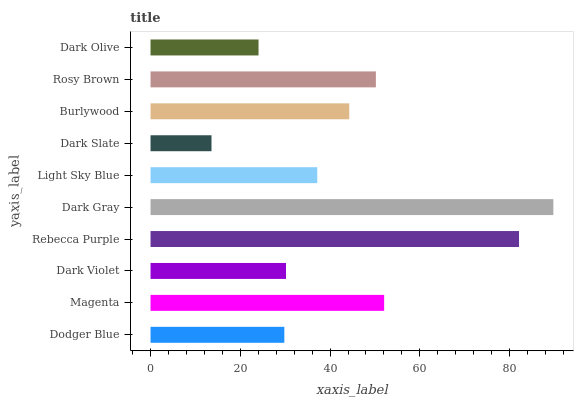Is Dark Slate the minimum?
Answer yes or no. Yes. Is Dark Gray the maximum?
Answer yes or no. Yes. Is Magenta the minimum?
Answer yes or no. No. Is Magenta the maximum?
Answer yes or no. No. Is Magenta greater than Dodger Blue?
Answer yes or no. Yes. Is Dodger Blue less than Magenta?
Answer yes or no. Yes. Is Dodger Blue greater than Magenta?
Answer yes or no. No. Is Magenta less than Dodger Blue?
Answer yes or no. No. Is Burlywood the high median?
Answer yes or no. Yes. Is Light Sky Blue the low median?
Answer yes or no. Yes. Is Dark Gray the high median?
Answer yes or no. No. Is Dodger Blue the low median?
Answer yes or no. No. 